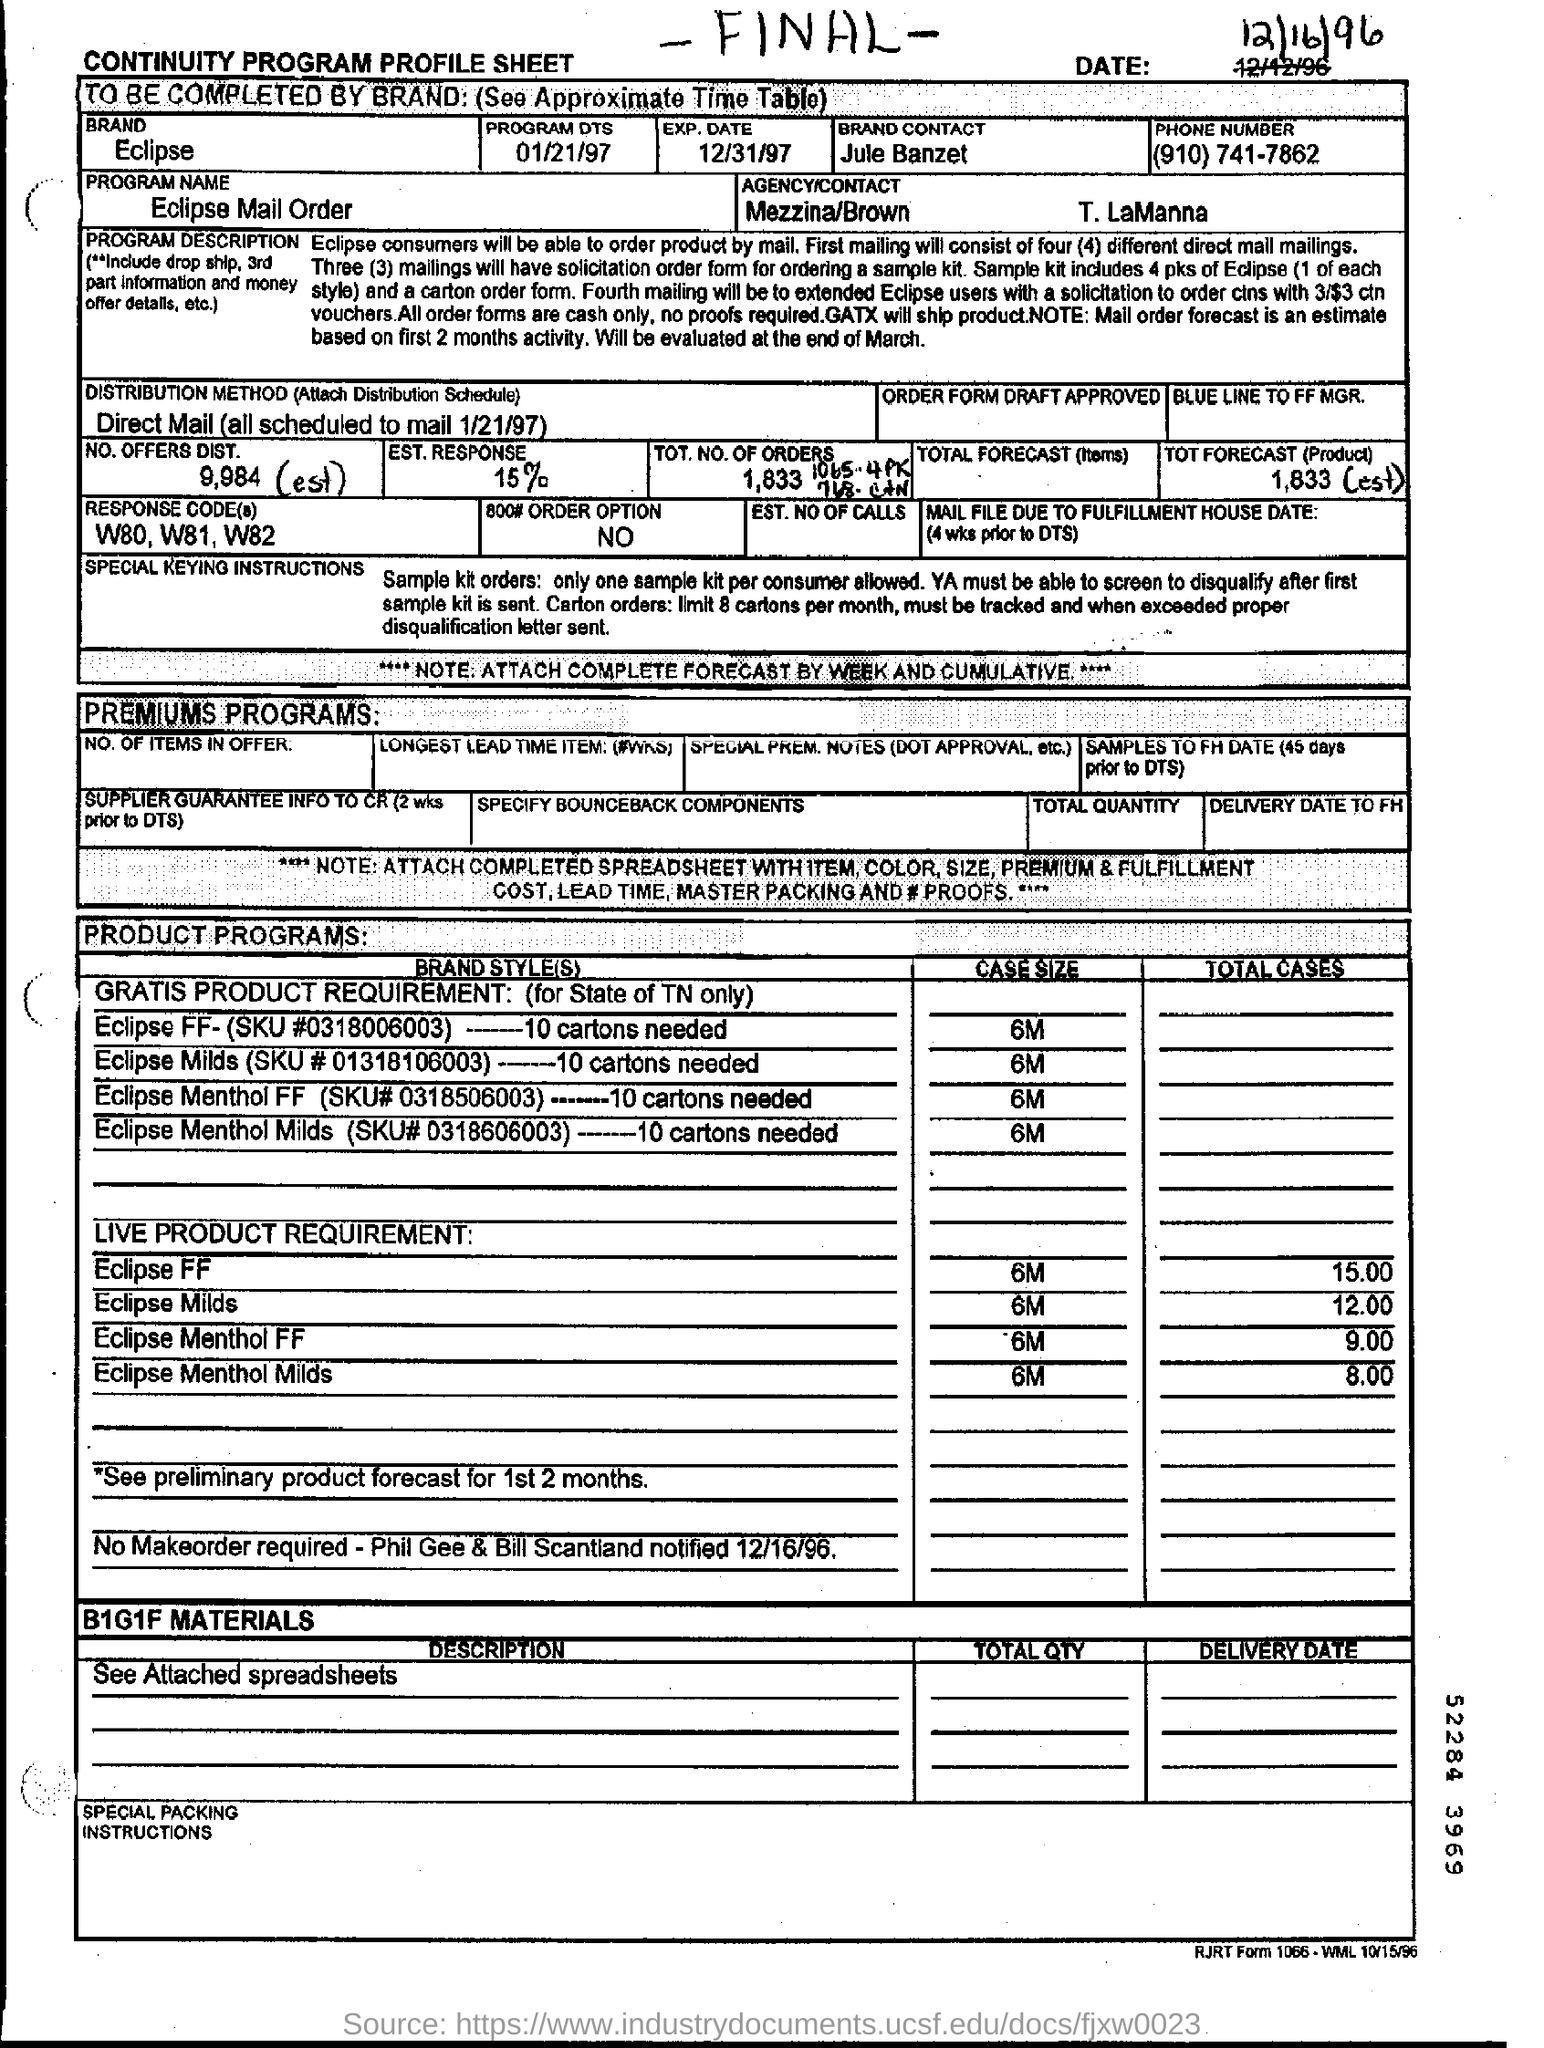What is the PROGRAM NAME?
Offer a terse response. Eclipse Mail Order. How many cartons of Eclipse FF are needed?
Ensure brevity in your answer.  10. What is the SKU # of Eclipse Menthol FF?
Give a very brief answer. 0318506003. 